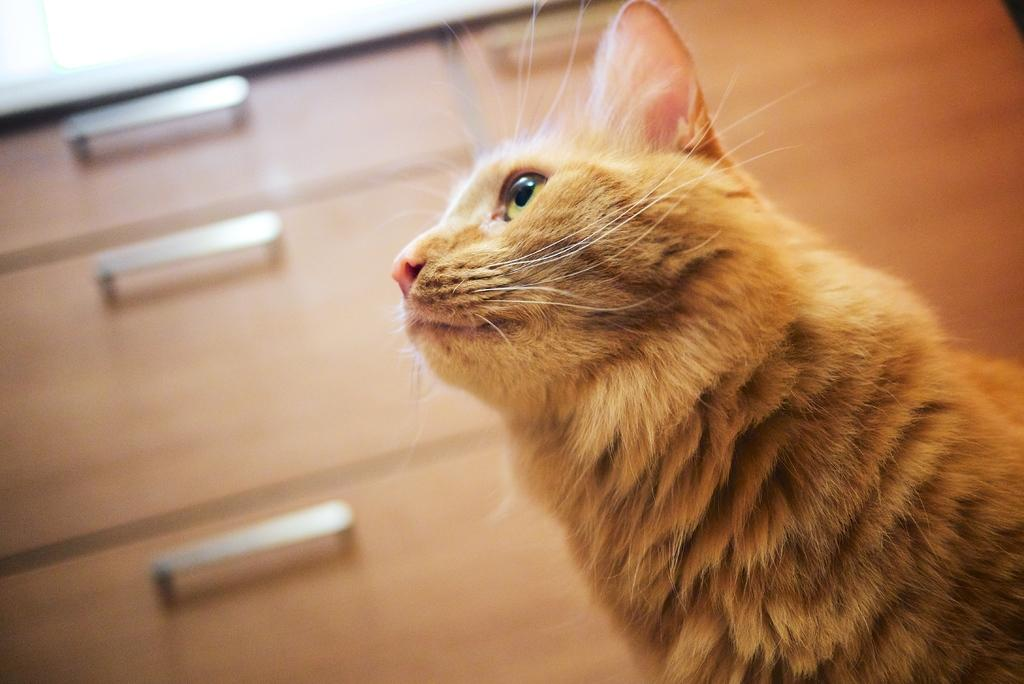What type of animal is in the image? There is a cat in the image. Where is the cat located in the image? The cat is towards the right side of the image. What color is the cat? The cat is brown in color. What type of furniture is visible in the image? There are cabinets with handles in the image. Where are the cabinets located in the image? The cabinets are towards the left side of the image. What type of yoke is being used by the scarecrow in the image? There is no scarecrow or yoke present in the image; it features a cat and cabinets. 